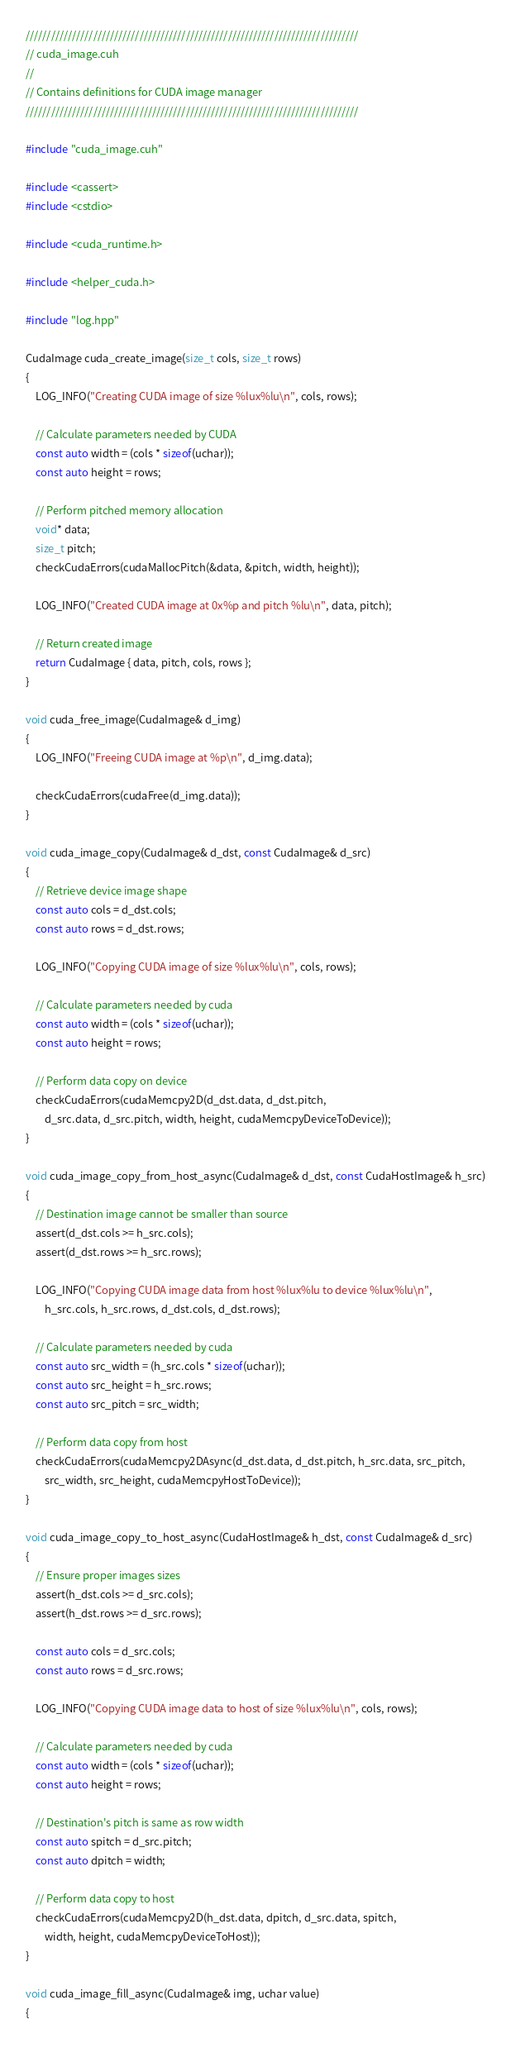<code> <loc_0><loc_0><loc_500><loc_500><_Cuda_>///////////////////////////////////////////////////////////////////////////////
// cuda_image.cuh
//
// Contains definitions for CUDA image manager
///////////////////////////////////////////////////////////////////////////////

#include "cuda_image.cuh"

#include <cassert>
#include <cstdio>

#include <cuda_runtime.h>

#include <helper_cuda.h>

#include "log.hpp"

CudaImage cuda_create_image(size_t cols, size_t rows)
{
	LOG_INFO("Creating CUDA image of size %lux%lu\n", cols, rows);

	// Calculate parameters needed by CUDA
	const auto width = (cols * sizeof(uchar));
	const auto height = rows;

	// Perform pitched memory allocation
	void* data;
	size_t pitch;
	checkCudaErrors(cudaMallocPitch(&data, &pitch, width, height));

	LOG_INFO("Created CUDA image at 0x%p and pitch %lu\n", data, pitch);

	// Return created image
	return CudaImage { data, pitch, cols, rows };
}

void cuda_free_image(CudaImage& d_img)
{
	LOG_INFO("Freeing CUDA image at %p\n", d_img.data);

	checkCudaErrors(cudaFree(d_img.data));
}

void cuda_image_copy(CudaImage& d_dst, const CudaImage& d_src)
{
	// Retrieve device image shape
	const auto cols = d_dst.cols;
	const auto rows = d_dst.rows;

	LOG_INFO("Copying CUDA image of size %lux%lu\n", cols, rows);

	// Calculate parameters needed by cuda
	const auto width = (cols * sizeof(uchar));
	const auto height = rows;

	// Perform data copy on device
	checkCudaErrors(cudaMemcpy2D(d_dst.data, d_dst.pitch,
		d_src.data, d_src.pitch, width, height, cudaMemcpyDeviceToDevice));
}

void cuda_image_copy_from_host_async(CudaImage& d_dst, const CudaHostImage& h_src)
{
	// Destination image cannot be smaller than source
	assert(d_dst.cols >= h_src.cols);
	assert(d_dst.rows >= h_src.rows);

	LOG_INFO("Copying CUDA image data from host %lux%lu to device %lux%lu\n", 
		h_src.cols, h_src.rows, d_dst.cols, d_dst.rows);

	// Calculate parameters needed by cuda
	const auto src_width = (h_src.cols * sizeof(uchar));
	const auto src_height = h_src.rows;
	const auto src_pitch = src_width;

	// Perform data copy from host
	checkCudaErrors(cudaMemcpy2DAsync(d_dst.data, d_dst.pitch, h_src.data, src_pitch,
		src_width, src_height, cudaMemcpyHostToDevice));
}

void cuda_image_copy_to_host_async(CudaHostImage& h_dst, const CudaImage& d_src)
{
	// Ensure proper images sizes
	assert(h_dst.cols >= d_src.cols);
	assert(h_dst.rows >= d_src.rows);
	
	const auto cols = d_src.cols;
	const auto rows = d_src.rows;

	LOG_INFO("Copying CUDA image data to host of size %lux%lu\n", cols, rows);

	// Calculate parameters needed by cuda
	const auto width = (cols * sizeof(uchar));
	const auto height = rows;

	// Destination's pitch is same as row width
	const auto spitch = d_src.pitch;
	const auto dpitch = width;

	// Perform data copy to host
	checkCudaErrors(cudaMemcpy2D(h_dst.data, dpitch, d_src.data, spitch,
		width, height, cudaMemcpyDeviceToHost));	
}

void cuda_image_fill_async(CudaImage& img, uchar value)
{</code> 